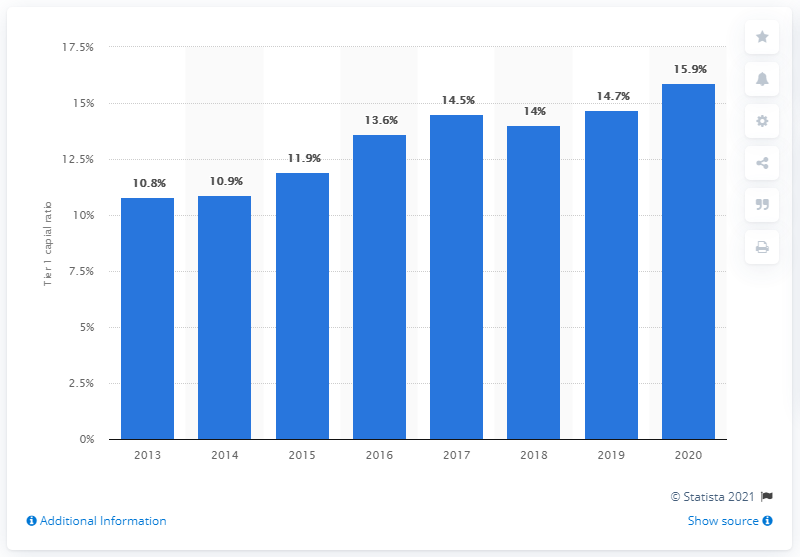Point out several critical features in this image. In 2020, HSBC's common equity tier 1 capital ratio was 15.9%. The tier 1 capital ratio of HSBC a year earlier was 14.7. 